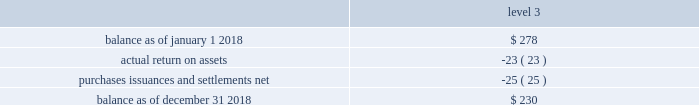Asset category target allocation total quoted prices in active markets for identical assets ( level 1 ) significant observable inputs ( level 2 ) significant unobservable inputs .
Balance as of january 1 , 2017 .
$ 140 actual return on assets .
2 purchases , issuances and settlements , net .
136 balance as of december 31 , 2017 .
$ 278 the company 2019s postretirement benefit plans have different levels of funded status and the assets are held under various trusts .
The investments and risk mitigation strategies for the plans are tailored specifically for each trust .
In setting new strategic asset mixes , consideration is given to the likelihood that the selected asset allocation will effectively fund the projected plan liabilities and meet the risk tolerance criteria of the company .
The company periodically updates the long-term , strategic asset allocations for these plans through asset liability studies and uses various analytics to determine the optimal asset allocation .
Considerations include plan liability characteristics , liquidity needs , funding requirements , expected rates of return and the distribution of returns .
In 2012 , the company implemented a de-risking strategy for the american water pension plan after conducting an asset-liability study to reduce the volatility of the funded status of the plan .
As part of the de-risking strategy , the company revised the asset allocations to increase the matching characteristics of fixed- income assets relative to liabilities .
The fixed income portion of the portfolio was designed to match the bond- .
What was the change in value for level 3 inputs during 2018?\\n? 
Computations: (230 - 278)
Answer: -48.0. Asset category target allocation total quoted prices in active markets for identical assets ( level 1 ) significant observable inputs ( level 2 ) significant unobservable inputs .
Balance as of january 1 , 2017 .
$ 140 actual return on assets .
2 purchases , issuances and settlements , net .
136 balance as of december 31 , 2017 .
$ 278 the company 2019s postretirement benefit plans have different levels of funded status and the assets are held under various trusts .
The investments and risk mitigation strategies for the plans are tailored specifically for each trust .
In setting new strategic asset mixes , consideration is given to the likelihood that the selected asset allocation will effectively fund the projected plan liabilities and meet the risk tolerance criteria of the company .
The company periodically updates the long-term , strategic asset allocations for these plans through asset liability studies and uses various analytics to determine the optimal asset allocation .
Considerations include plan liability characteristics , liquidity needs , funding requirements , expected rates of return and the distribution of returns .
In 2012 , the company implemented a de-risking strategy for the american water pension plan after conducting an asset-liability study to reduce the volatility of the funded status of the plan .
As part of the de-risking strategy , the company revised the asset allocations to increase the matching characteristics of fixed- income assets relative to liabilities .
The fixed income portion of the portfolio was designed to match the bond- .
Was actual return on assets greater than purchases issuances and settlements? 
Computations: ((23 * const_m1) > -25)
Answer: yes. 